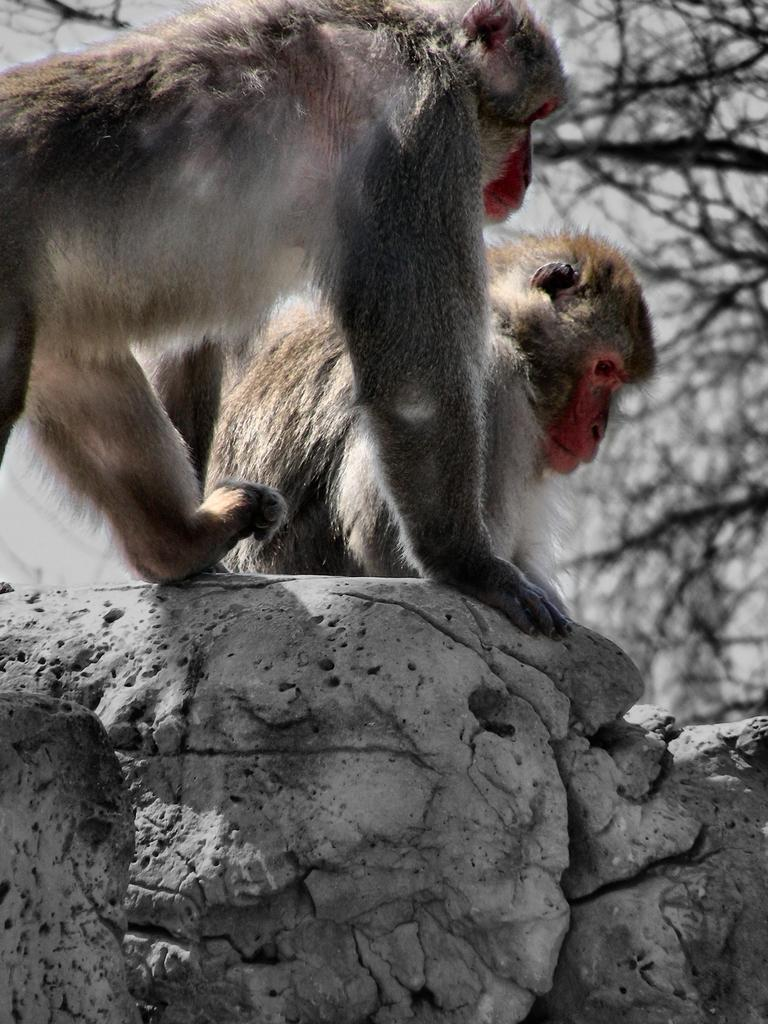How many monkeys are present in the image? There are two monkeys in the image. Where are the monkeys located? The monkeys are on a rock. What can be seen in the background of the image? There are trees in the background of the image. What type of brass instrument is being played by the monkeys in the image? There is no brass instrument present in the image; it features two monkeys on a rock with trees in the background. 